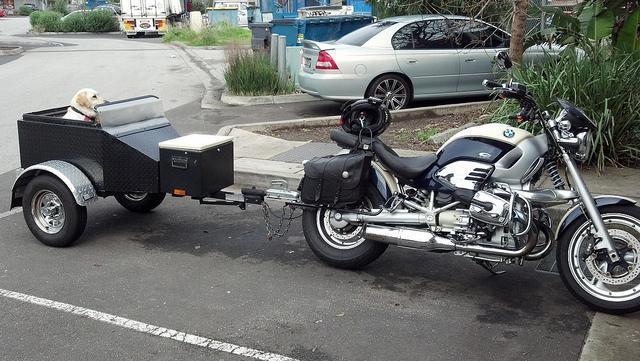How many people are wearing white shirt?
Give a very brief answer. 0. 